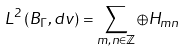<formula> <loc_0><loc_0><loc_500><loc_500>L ^ { 2 } \left ( B _ { \Gamma } , d v \right ) = \sum _ { m , n \in \mathbb { Z } } \oplus H _ { m n }</formula> 